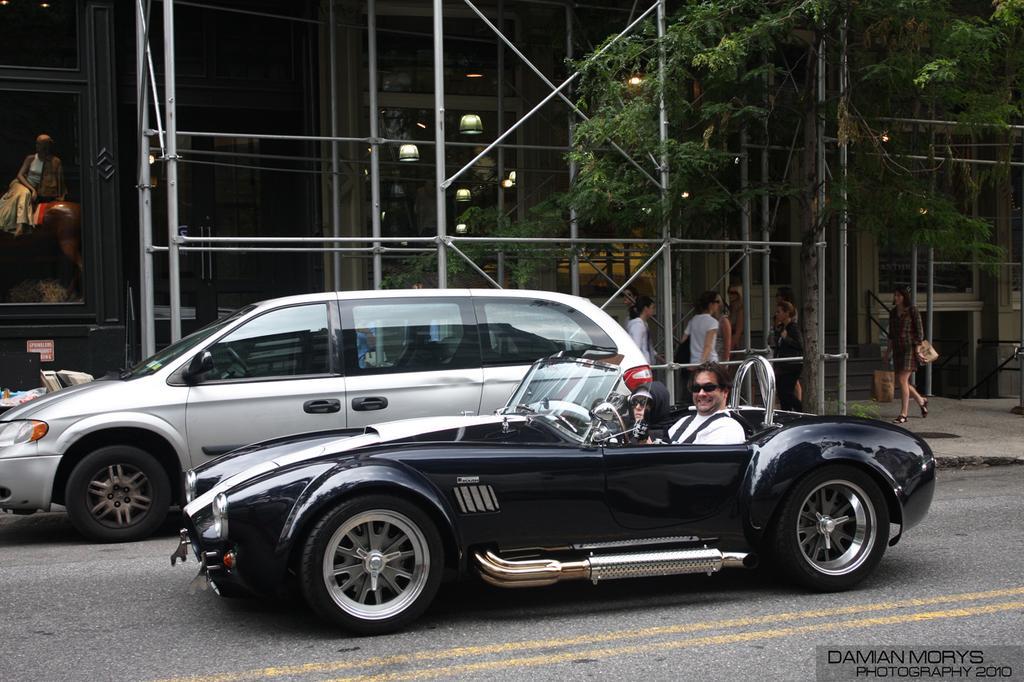How would you summarize this image in a sentence or two? In the image there are two cars on the road with two men inside it in the front car, in the back there is a metal frame in front of a building beside a tree and there are few people walking on the footpath. 